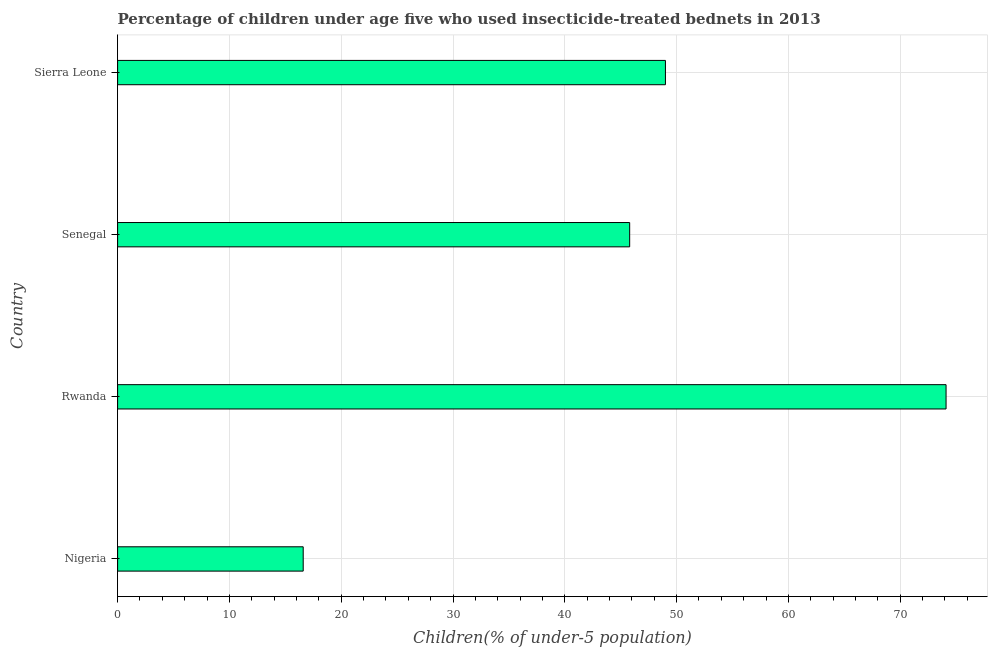Does the graph contain grids?
Your response must be concise. Yes. What is the title of the graph?
Your answer should be very brief. Percentage of children under age five who used insecticide-treated bednets in 2013. What is the label or title of the X-axis?
Keep it short and to the point. Children(% of under-5 population). What is the label or title of the Y-axis?
Give a very brief answer. Country. What is the percentage of children who use of insecticide-treated bed nets in Senegal?
Ensure brevity in your answer.  45.8. Across all countries, what is the maximum percentage of children who use of insecticide-treated bed nets?
Provide a short and direct response. 74.1. Across all countries, what is the minimum percentage of children who use of insecticide-treated bed nets?
Your response must be concise. 16.6. In which country was the percentage of children who use of insecticide-treated bed nets maximum?
Offer a very short reply. Rwanda. In which country was the percentage of children who use of insecticide-treated bed nets minimum?
Provide a short and direct response. Nigeria. What is the sum of the percentage of children who use of insecticide-treated bed nets?
Provide a short and direct response. 185.5. What is the difference between the percentage of children who use of insecticide-treated bed nets in Senegal and Sierra Leone?
Offer a terse response. -3.2. What is the average percentage of children who use of insecticide-treated bed nets per country?
Your answer should be compact. 46.38. What is the median percentage of children who use of insecticide-treated bed nets?
Make the answer very short. 47.4. What is the ratio of the percentage of children who use of insecticide-treated bed nets in Senegal to that in Sierra Leone?
Give a very brief answer. 0.94. Is the percentage of children who use of insecticide-treated bed nets in Nigeria less than that in Sierra Leone?
Keep it short and to the point. Yes. What is the difference between the highest and the second highest percentage of children who use of insecticide-treated bed nets?
Offer a very short reply. 25.1. Is the sum of the percentage of children who use of insecticide-treated bed nets in Senegal and Sierra Leone greater than the maximum percentage of children who use of insecticide-treated bed nets across all countries?
Offer a very short reply. Yes. What is the difference between the highest and the lowest percentage of children who use of insecticide-treated bed nets?
Ensure brevity in your answer.  57.5. How many bars are there?
Provide a short and direct response. 4. Are all the bars in the graph horizontal?
Provide a succinct answer. Yes. How many countries are there in the graph?
Make the answer very short. 4. What is the difference between two consecutive major ticks on the X-axis?
Keep it short and to the point. 10. What is the Children(% of under-5 population) of Nigeria?
Offer a very short reply. 16.6. What is the Children(% of under-5 population) of Rwanda?
Ensure brevity in your answer.  74.1. What is the Children(% of under-5 population) of Senegal?
Your answer should be compact. 45.8. What is the Children(% of under-5 population) in Sierra Leone?
Offer a very short reply. 49. What is the difference between the Children(% of under-5 population) in Nigeria and Rwanda?
Your answer should be very brief. -57.5. What is the difference between the Children(% of under-5 population) in Nigeria and Senegal?
Provide a succinct answer. -29.2. What is the difference between the Children(% of under-5 population) in Nigeria and Sierra Leone?
Your answer should be very brief. -32.4. What is the difference between the Children(% of under-5 population) in Rwanda and Senegal?
Ensure brevity in your answer.  28.3. What is the difference between the Children(% of under-5 population) in Rwanda and Sierra Leone?
Your answer should be compact. 25.1. What is the difference between the Children(% of under-5 population) in Senegal and Sierra Leone?
Your answer should be very brief. -3.2. What is the ratio of the Children(% of under-5 population) in Nigeria to that in Rwanda?
Provide a succinct answer. 0.22. What is the ratio of the Children(% of under-5 population) in Nigeria to that in Senegal?
Provide a succinct answer. 0.36. What is the ratio of the Children(% of under-5 population) in Nigeria to that in Sierra Leone?
Ensure brevity in your answer.  0.34. What is the ratio of the Children(% of under-5 population) in Rwanda to that in Senegal?
Keep it short and to the point. 1.62. What is the ratio of the Children(% of under-5 population) in Rwanda to that in Sierra Leone?
Make the answer very short. 1.51. What is the ratio of the Children(% of under-5 population) in Senegal to that in Sierra Leone?
Provide a short and direct response. 0.94. 